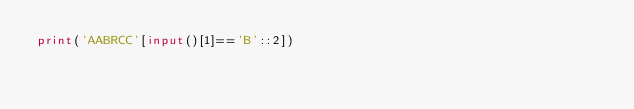<code> <loc_0><loc_0><loc_500><loc_500><_Python_>print('AABRCC'[input()[1]=='B'::2])</code> 